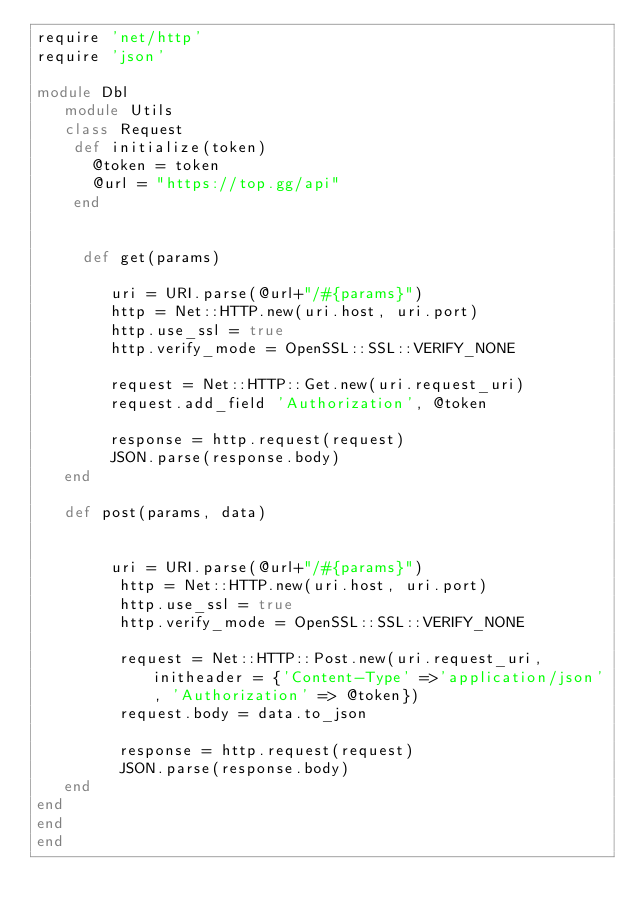<code> <loc_0><loc_0><loc_500><loc_500><_Ruby_>require 'net/http'
require 'json'

module Dbl 
   module Utils
   class Request
    def initialize(token)
      @token = token
      @url = "https://top.gg/api"
    end
        
   
     def get(params)
        
        uri = URI.parse(@url+"/#{params}")
        http = Net::HTTP.new(uri.host, uri.port)
        http.use_ssl = true
        http.verify_mode = OpenSSL::SSL::VERIFY_NONE

        request = Net::HTTP::Get.new(uri.request_uri)
        request.add_field 'Authorization', @token

        response = http.request(request)
        JSON.parse(response.body)
   end

   def post(params, data)


        uri = URI.parse(@url+"/#{params}")
         http = Net::HTTP.new(uri.host, uri.port)
         http.use_ssl = true
         http.verify_mode = OpenSSL::SSL::VERIFY_NONE

         request = Net::HTTP::Post.new(uri.request_uri, initheader = {'Content-Type' =>'application/json', 'Authorization' => @token})
         request.body = data.to_json

         response = http.request(request)
         JSON.parse(response.body)
   end
end
end
end</code> 